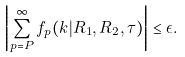<formula> <loc_0><loc_0><loc_500><loc_500>\left | \sum _ { p = P } ^ { \infty } f _ { p } ( k | R _ { 1 } , R _ { 2 } , { \tau } ) \right | \leq \epsilon .</formula> 